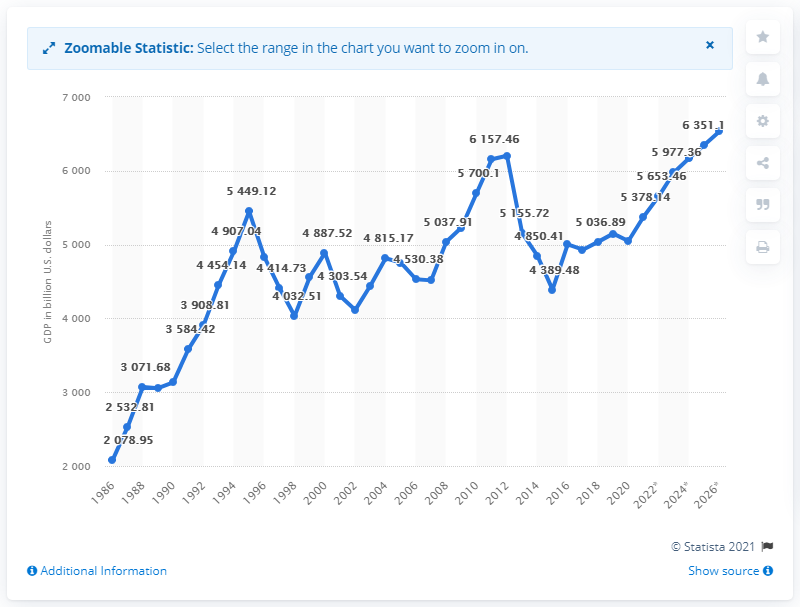Highlight a few significant elements in this photo. In 2019, Japan's gross domestic product (GDP) was 51,48.78 billion. 